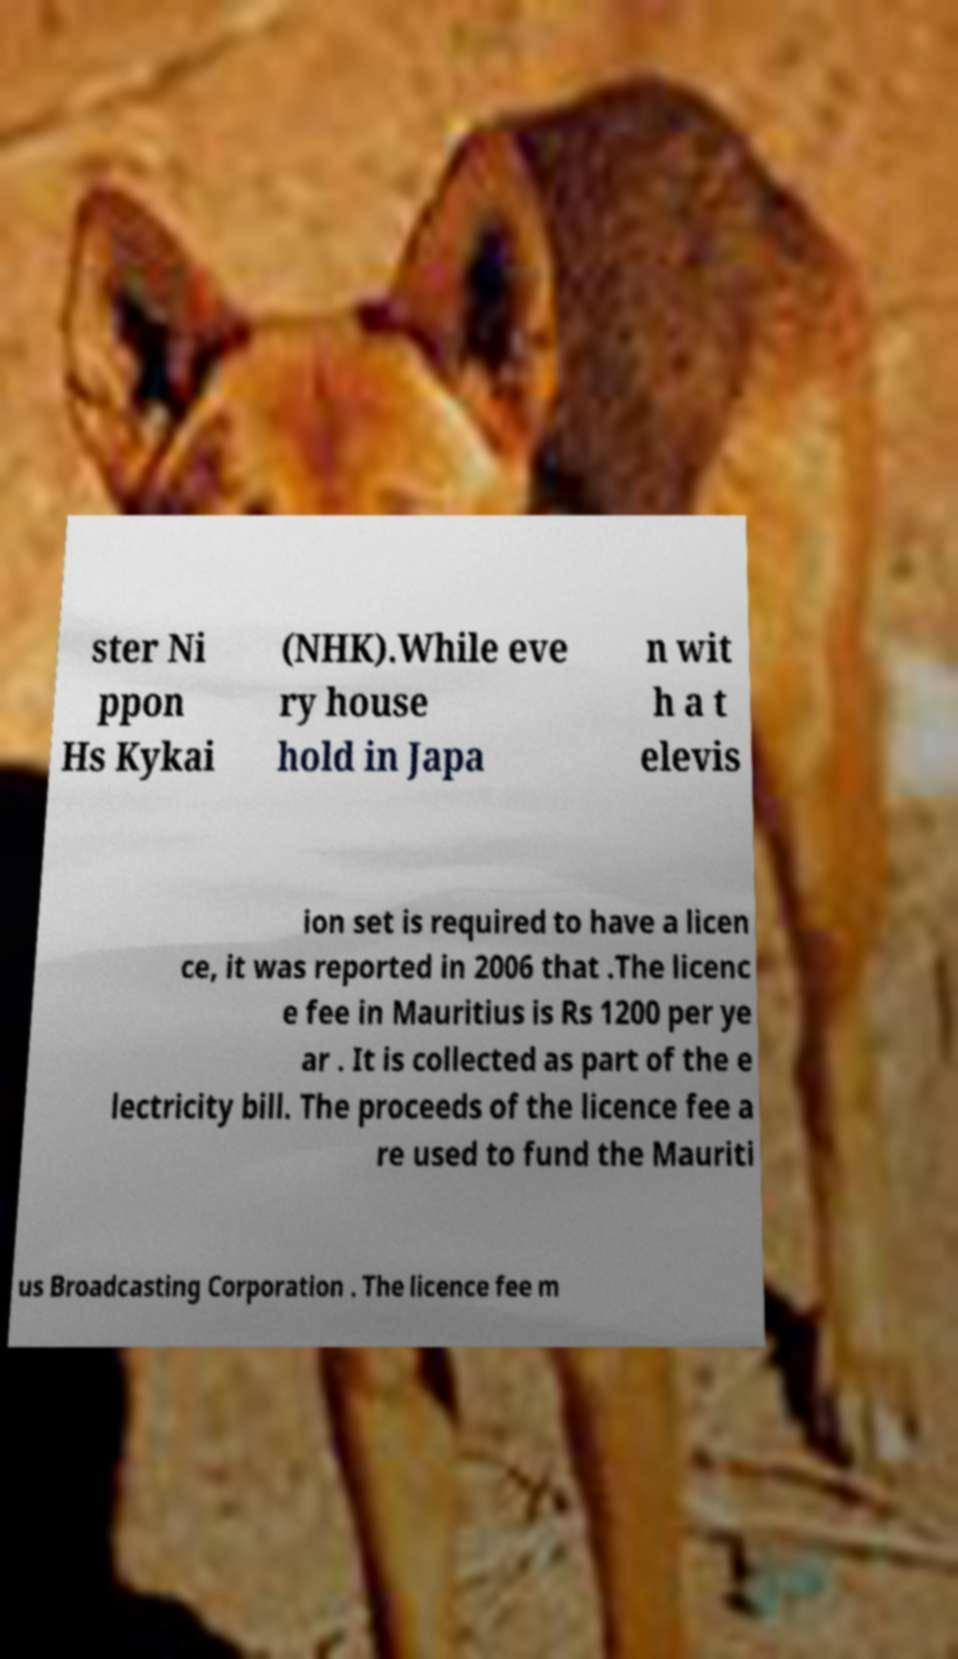Could you assist in decoding the text presented in this image and type it out clearly? ster Ni ppon Hs Kykai (NHK).While eve ry house hold in Japa n wit h a t elevis ion set is required to have a licen ce, it was reported in 2006 that .The licenc e fee in Mauritius is Rs 1200 per ye ar . It is collected as part of the e lectricity bill. The proceeds of the licence fee a re used to fund the Mauriti us Broadcasting Corporation . The licence fee m 